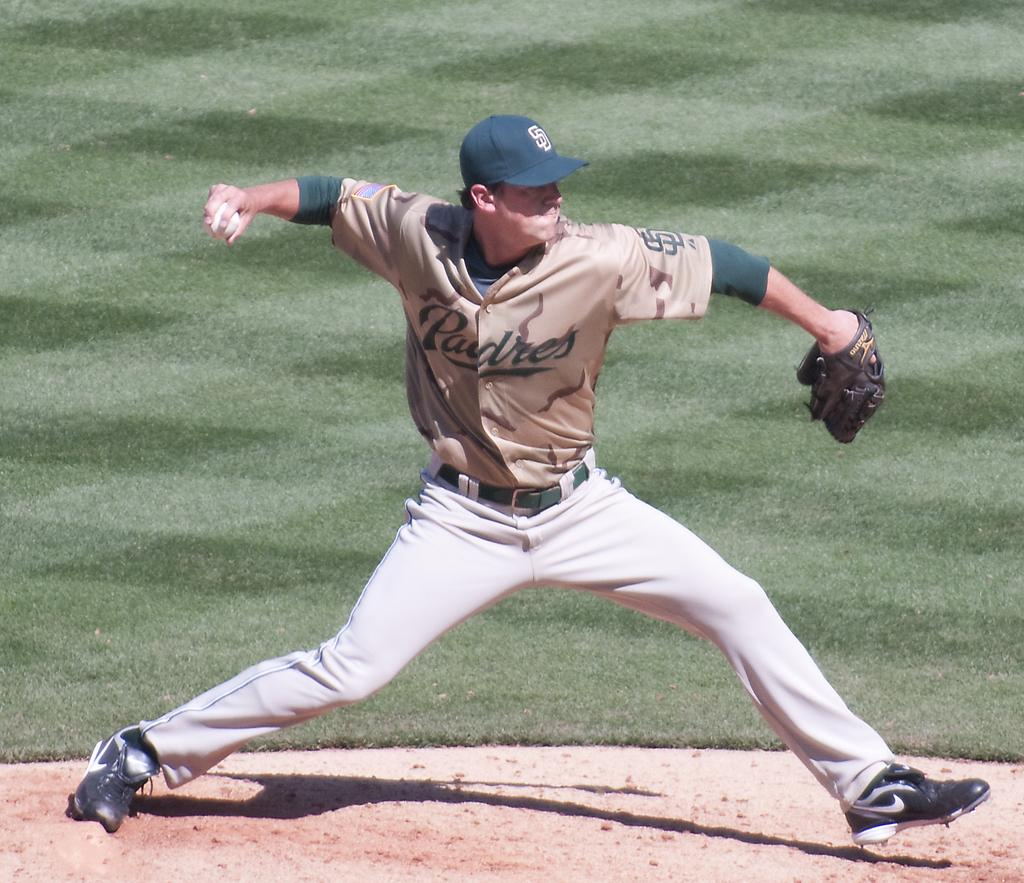<image>
Offer a succinct explanation of the picture presented. A Padres Baseball Pitcher winds up for the Pitch. 